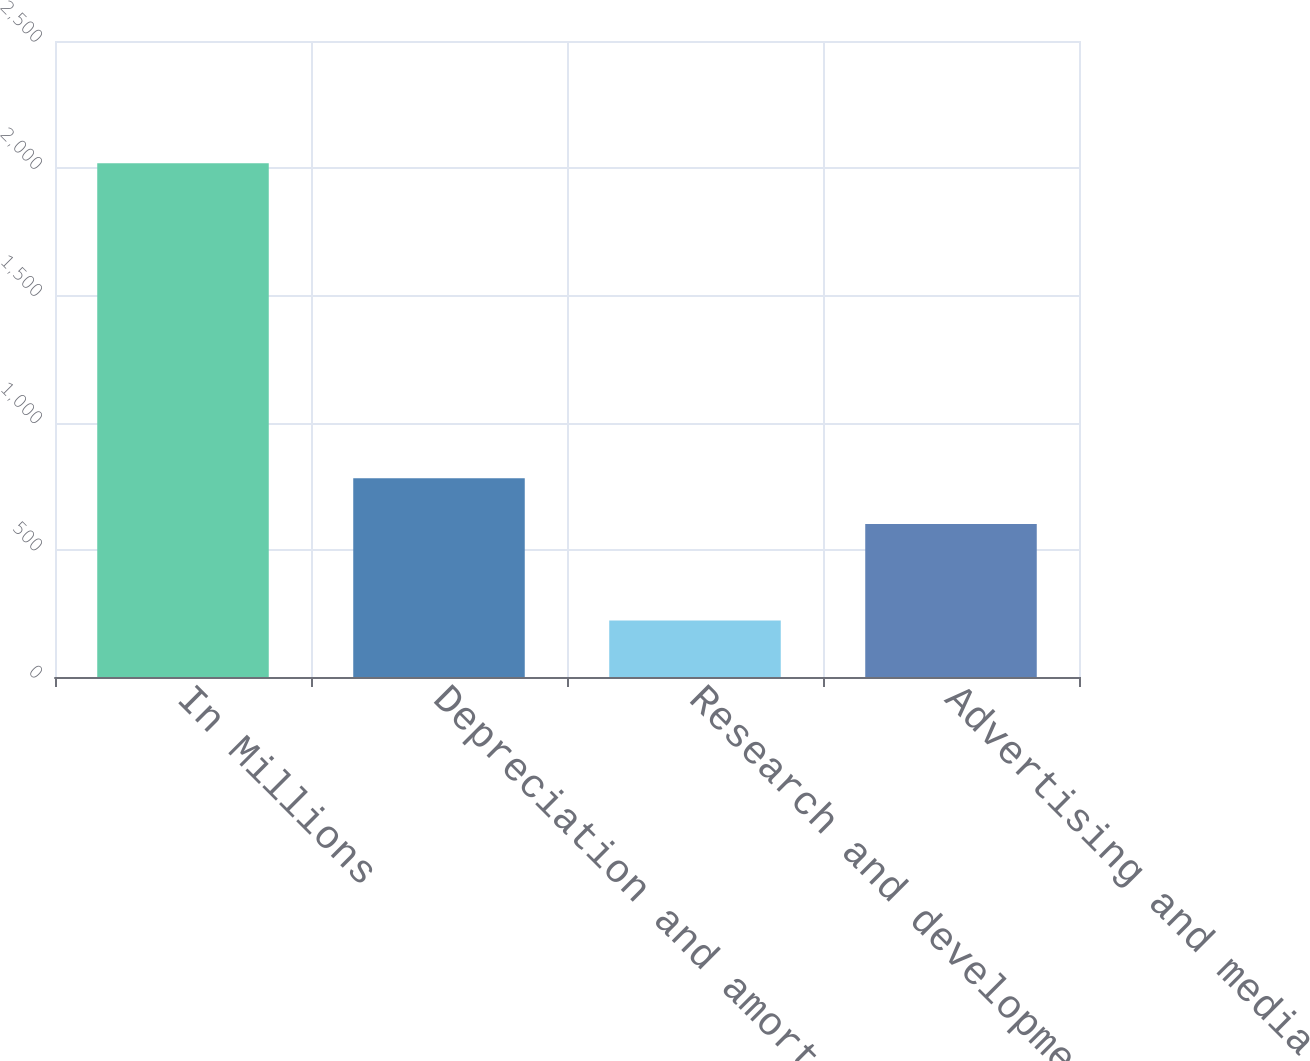Convert chart to OTSL. <chart><loc_0><loc_0><loc_500><loc_500><bar_chart><fcel>In Millions<fcel>Depreciation and amortization<fcel>Research and development<fcel>Advertising and media expense<nl><fcel>2019<fcel>781.31<fcel>221.9<fcel>601.6<nl></chart> 